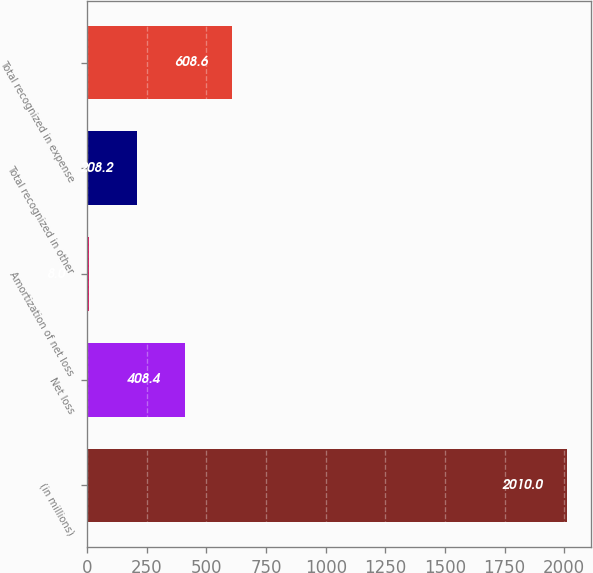<chart> <loc_0><loc_0><loc_500><loc_500><bar_chart><fcel>(in millions)<fcel>Net loss<fcel>Amortization of net loss<fcel>Total recognized in other<fcel>Total recognized in expense<nl><fcel>2010<fcel>408.4<fcel>8<fcel>208.2<fcel>608.6<nl></chart> 